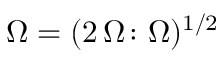<formula> <loc_0><loc_0><loc_500><loc_500>\Omega = ( 2 \, \Omega \colon \Omega ) ^ { 1 / 2 }</formula> 